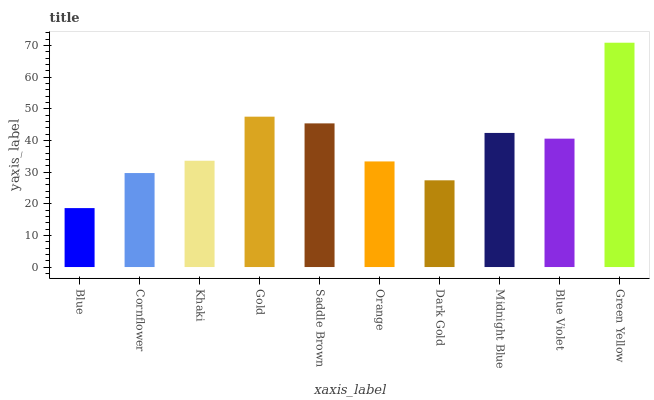Is Cornflower the minimum?
Answer yes or no. No. Is Cornflower the maximum?
Answer yes or no. No. Is Cornflower greater than Blue?
Answer yes or no. Yes. Is Blue less than Cornflower?
Answer yes or no. Yes. Is Blue greater than Cornflower?
Answer yes or no. No. Is Cornflower less than Blue?
Answer yes or no. No. Is Blue Violet the high median?
Answer yes or no. Yes. Is Khaki the low median?
Answer yes or no. Yes. Is Dark Gold the high median?
Answer yes or no. No. Is Blue Violet the low median?
Answer yes or no. No. 